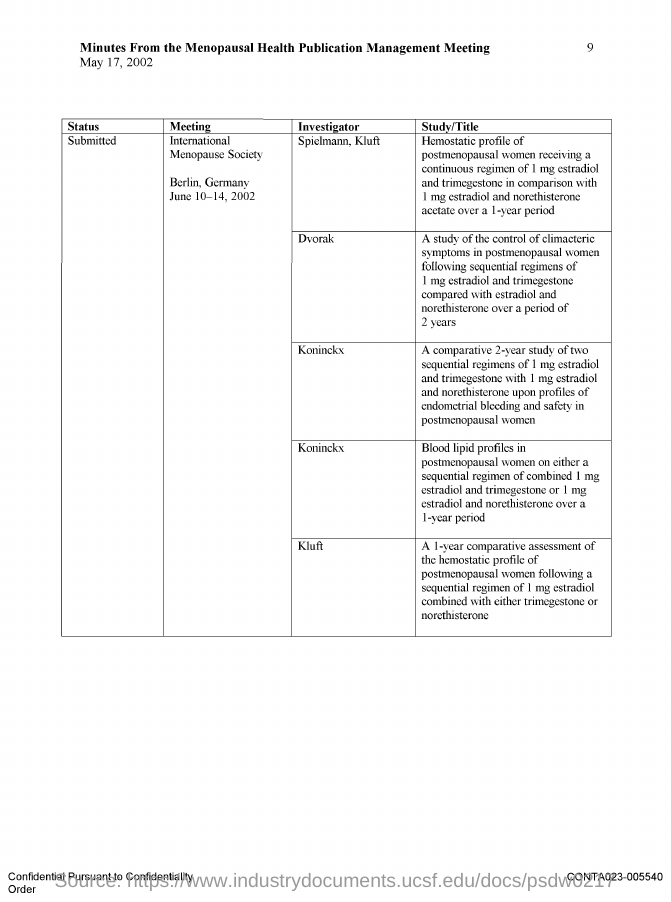Which Meeting is Spielmann, Kluft an Investigator of?
Provide a succinct answer. International Menopause Society. Which Meeting is Dvorak an Investigator of?
Provide a short and direct response. International Menopause Society. Which Meeting is Koninckx an Investigator of?
Provide a succinct answer. International Menopause Society. What is the date on the document?
Provide a succinct answer. May 17, 2002. Where is the International Menopause Society Meeting held?
Your answer should be very brief. Berlin, Germany. When is the International Menopause Society Meeting held?
Make the answer very short. June 10-14, 2002. 